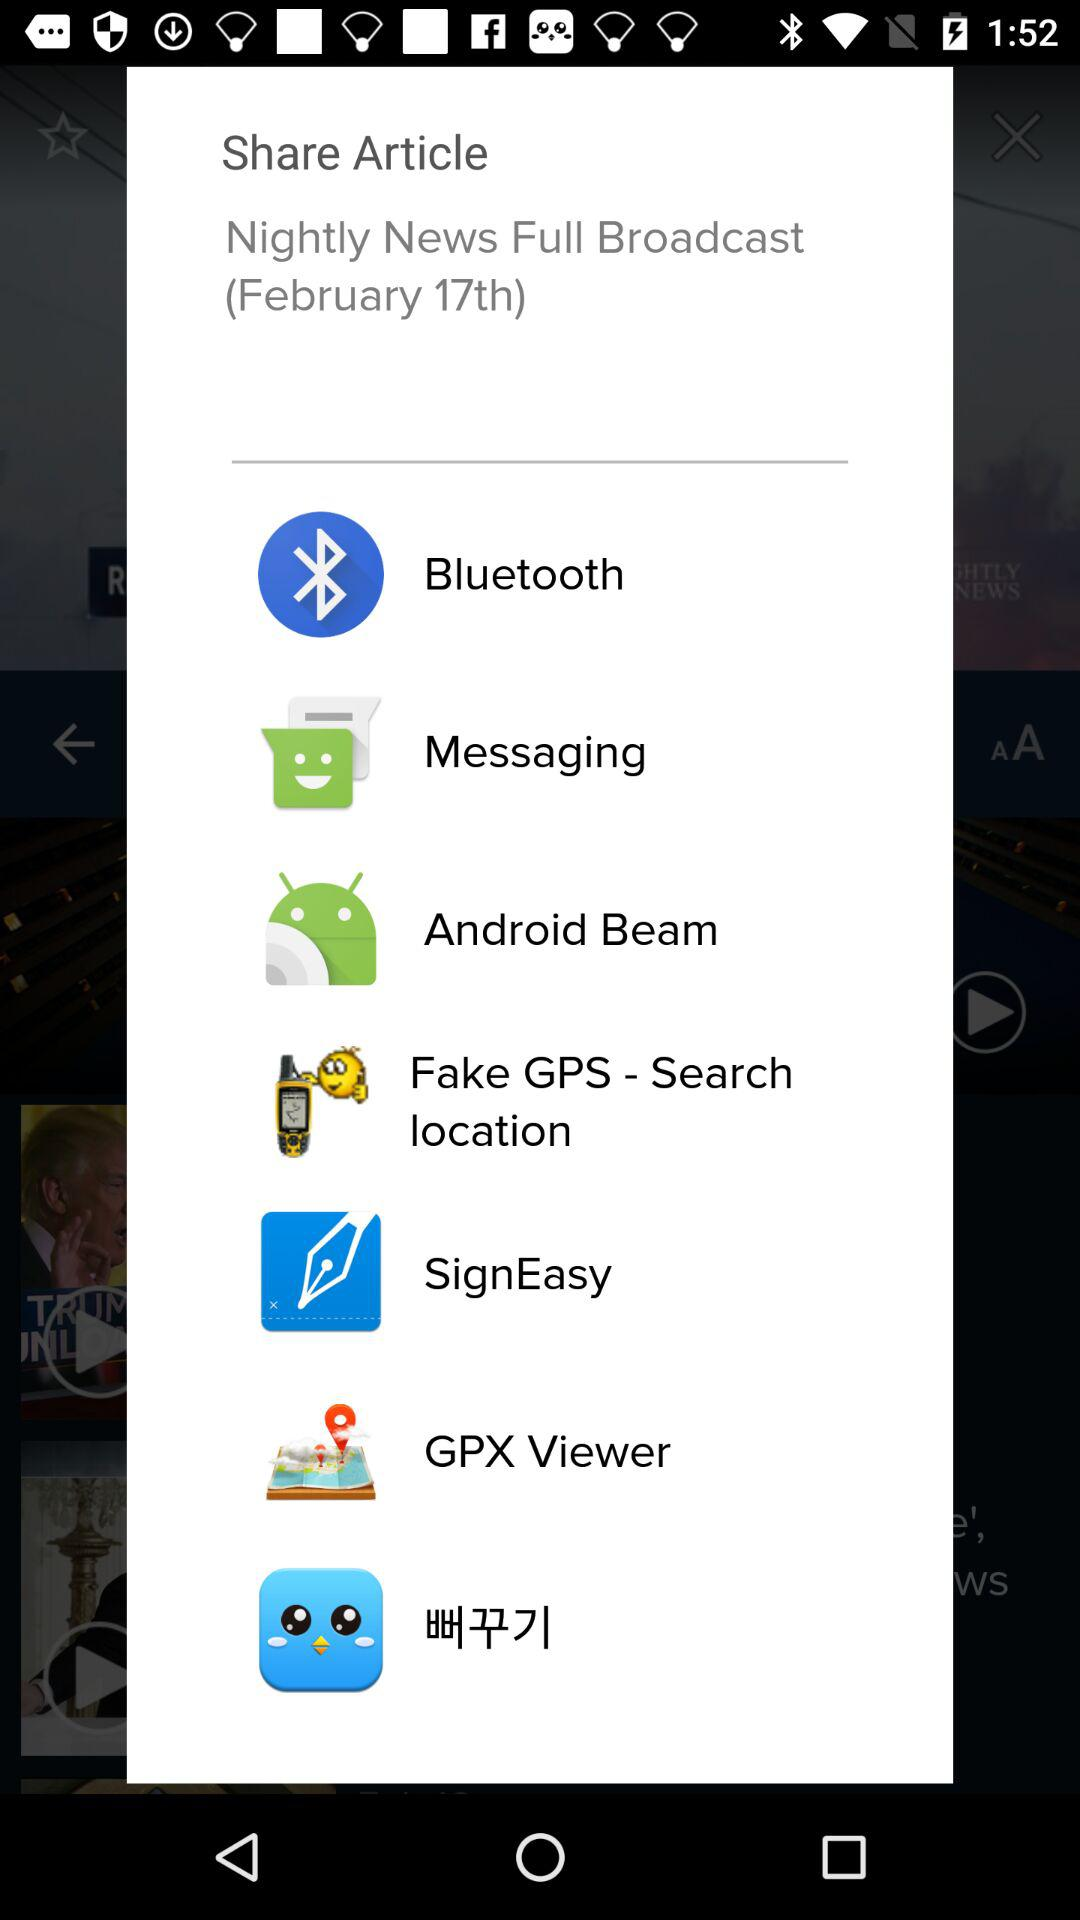Who's the publisher of the Article?
When the provided information is insufficient, respond with <no answer>. <no answer> 